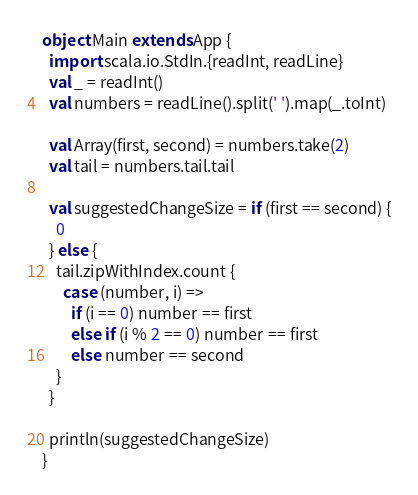Convert code to text. <code><loc_0><loc_0><loc_500><loc_500><_Scala_>object Main extends App {
  import scala.io.StdIn.{readInt, readLine}
  val _ = readInt()
  val numbers = readLine().split(' ').map(_.toInt)

  val Array(first, second) = numbers.take(2)
  val tail = numbers.tail.tail

  val suggestedChangeSize = if (first == second) {
    0
  } else {
    tail.zipWithIndex.count {
      case (number, i) =>
        if (i == 0) number == first
        else if (i % 2 == 0) number == first
        else number == second
    }
  }

  println(suggestedChangeSize)
}</code> 